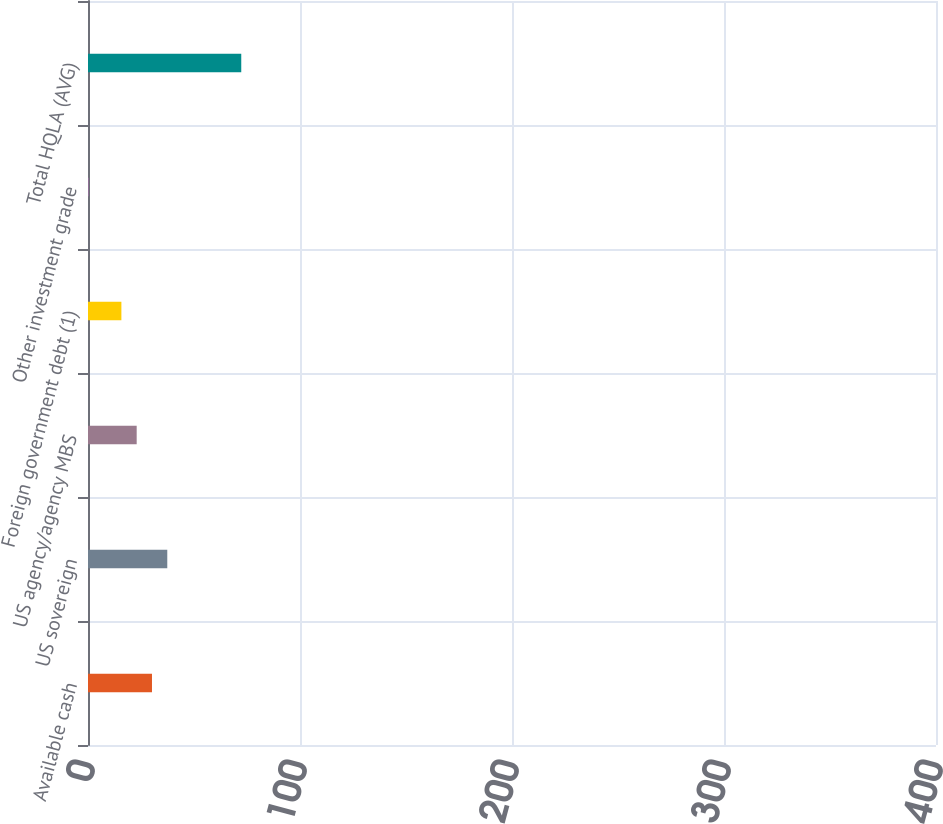Convert chart. <chart><loc_0><loc_0><loc_500><loc_500><bar_chart><fcel>Available cash<fcel>US sovereign<fcel>US agency/agency MBS<fcel>Foreign government debt (1)<fcel>Other investment grade<fcel>Total HQLA (AVG)<nl><fcel>154.26<fcel>191.14<fcel>117.38<fcel>80.5<fcel>0.7<fcel>369.5<nl></chart> 